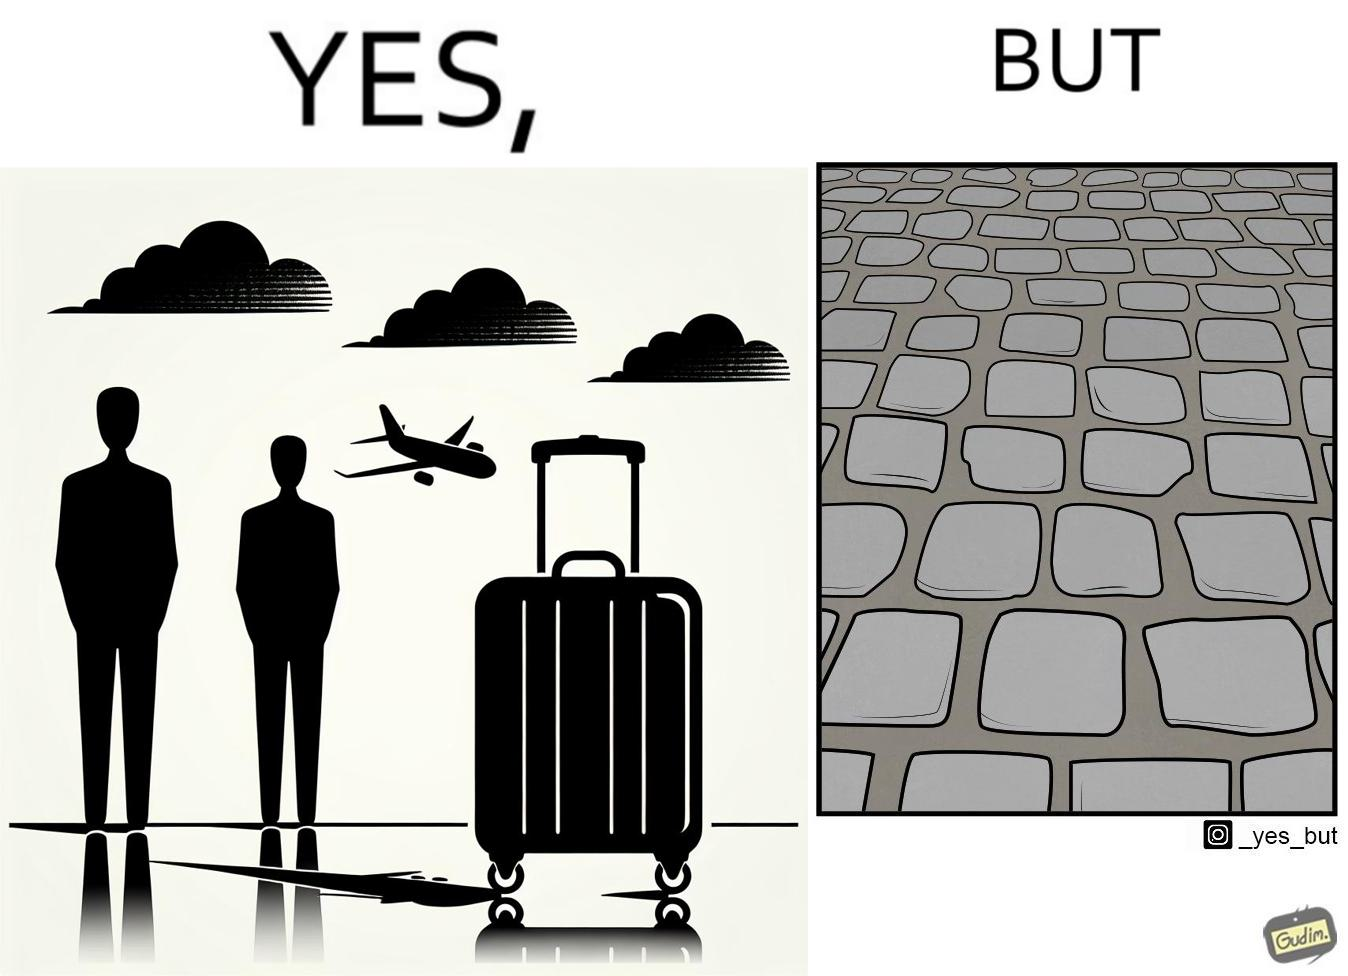What is shown in the left half versus the right half of this image? In the left part of the image: it is a trolley luggage bag In the right part of the image: It is a cobblestone road 